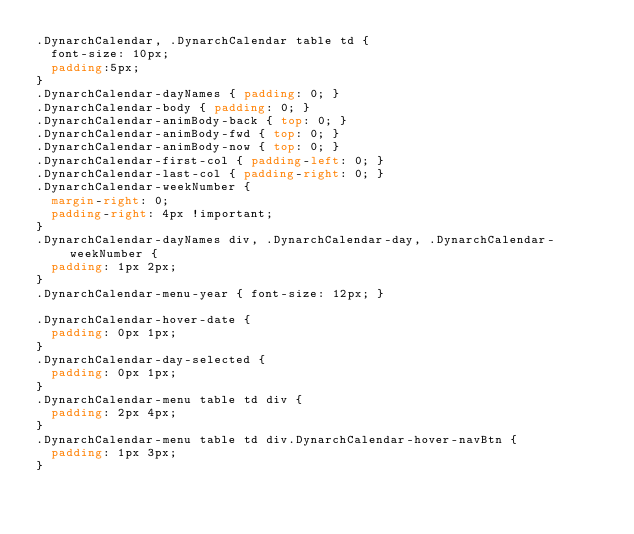Convert code to text. <code><loc_0><loc_0><loc_500><loc_500><_CSS_>.DynarchCalendar, .DynarchCalendar table td {
  font-size: 10px;
  padding:5px;
}
.DynarchCalendar-dayNames { padding: 0; }
.DynarchCalendar-body { padding: 0; }
.DynarchCalendar-animBody-back { top: 0; }
.DynarchCalendar-animBody-fwd { top: 0; }
.DynarchCalendar-animBody-now { top: 0; }
.DynarchCalendar-first-col { padding-left: 0; }
.DynarchCalendar-last-col { padding-right: 0; }
.DynarchCalendar-weekNumber {
  margin-right: 0;
  padding-right: 4px !important;
}
.DynarchCalendar-dayNames div, .DynarchCalendar-day, .DynarchCalendar-weekNumber {
  padding: 1px 2px;
}
.DynarchCalendar-menu-year { font-size: 12px; }

.DynarchCalendar-hover-date {
  padding: 0px 1px;
}
.DynarchCalendar-day-selected {
  padding: 0px 1px;
}
.DynarchCalendar-menu table td div {
  padding: 2px 4px;
}
.DynarchCalendar-menu table td div.DynarchCalendar-hover-navBtn {
  padding: 1px 3px;
}
</code> 